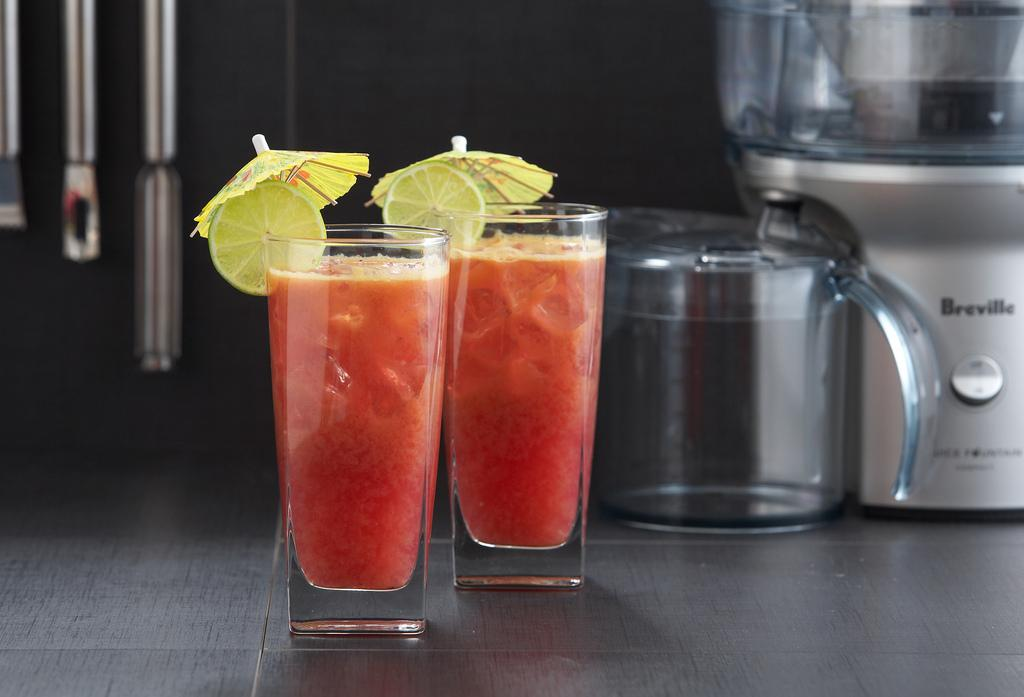<image>
Describe the image concisely. Two cocktails with umbrellas in front of a Breville machine. 